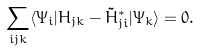<formula> <loc_0><loc_0><loc_500><loc_500>\sum _ { i j k } \langle \Psi _ { i } | H _ { j k } - \tilde { H } ^ { * } _ { j i } | \Psi _ { k } \rangle = 0 .</formula> 